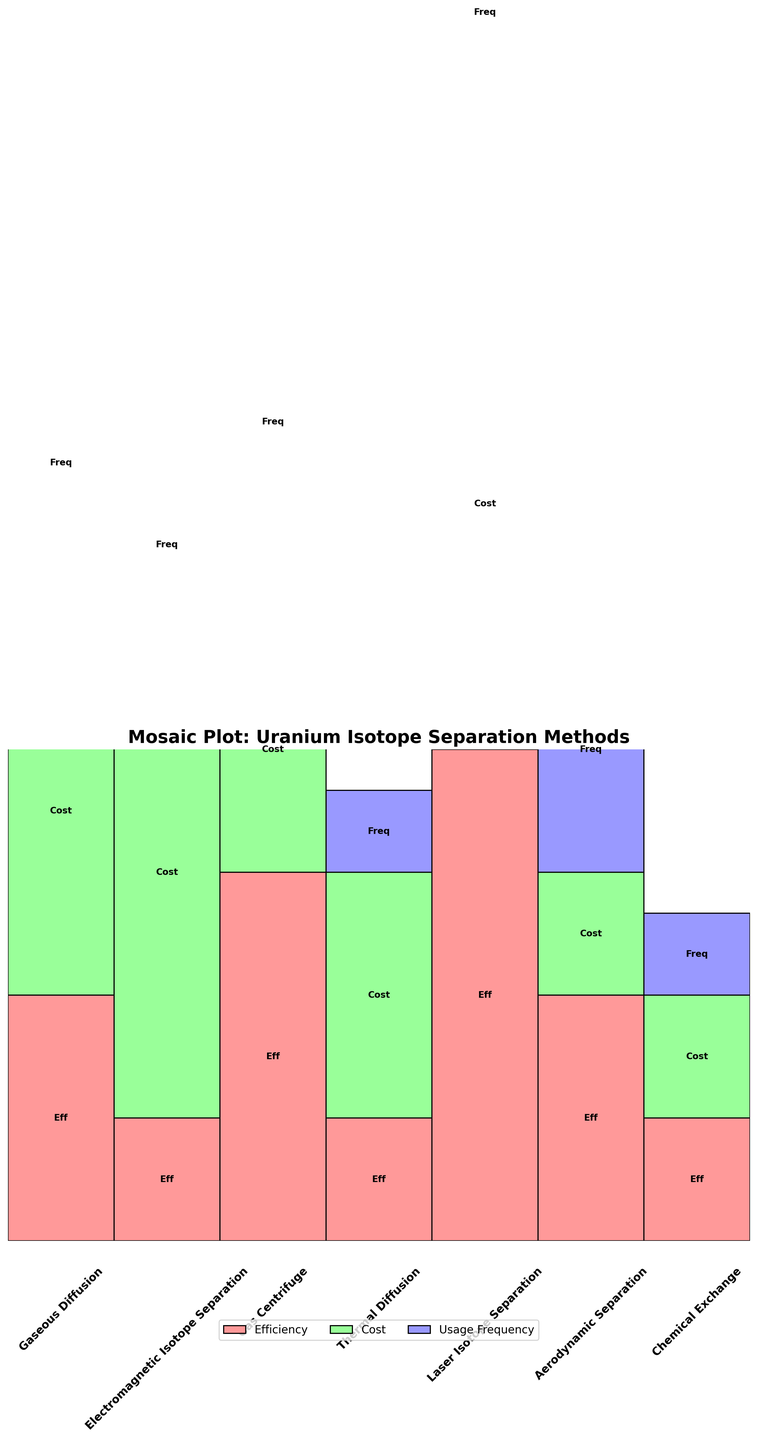What is the title of the mosaic plot? The title is usually found at the top of the plot and clearly indicates the subject of the visualization.
Answer: Mosaic Plot: Uranium Isotope Separation Methods How many separation methods are analyzed in the plot? You can determine the number of separation methods by counting the distinct method labels along the x-axis of the mosaic plot.
Answer: 7 Which uranium isotope separation method has the highest efficiency? The plot uses color-coding for efficiency, so you can identify the method with the tallest red ("#FF9999") rectangle within each segment.
Answer: Laser Isotope Separation What are the cost levels for the 'Gaseous Diffusion' and 'Gas Centrifuge' methods? By examining the green ("#99FF99") rectangles corresponding to these methods, you can identify their respective heights that indicate their cost levels.
Answer: High, Medium Which separation methods have a 'Low' frequency of usage? Find the blue ("#9999FF") rectangles with the shortest height within each segment and check the method labels below these segments.
Answer: Thermal Diffusion, Chemical Exchange Compare the efficiency and cost of the 'Aerodynamic Separation' and 'Electromagnetic Isotope Separation' methods. Compare the heights of the red and green rectangles for both methods to determine their efficiency and cost levels respectively.
Answer: Aerodynamic Separation: Medium efficiency, Low cost; Electromagnetic Isotope Separation: Low efficiency, Very High cost Which method is used most frequently? Look for the method with the tallest blue ("#9999FF") rectangle, which indicates the highest usage frequency.
Answer: Gaseous Diffusion How does the 'Electromagnetic Isotope Separation' method compare to 'Thermal Diffusion' in terms of cost and frequency? Compare the heights of the green and blue rectangles for these two methods to ascertain their cost and frequency levels respectively.
Answer: Electromagnetic Isotope Separation: Very High cost, Limited frequency; Thermal Diffusion: Medium cost, Rare frequency What's the relative cost of 'Laser Isotope Separation' compared to other methods? Identify the height of the green rectangle for 'Laser Isotope Separation' and compare it with the green rectangles of other methods to determine its relative cost.
Answer: Very High Which methods have the combination of high or very high efficiency and low or medium cost? Focus on methods where the red rectangle is tall (high or very high efficiency) and the green rectangle is short to medium height (low to medium cost).
Answer: Gas Centrifuge, Aerodynamic Separation 